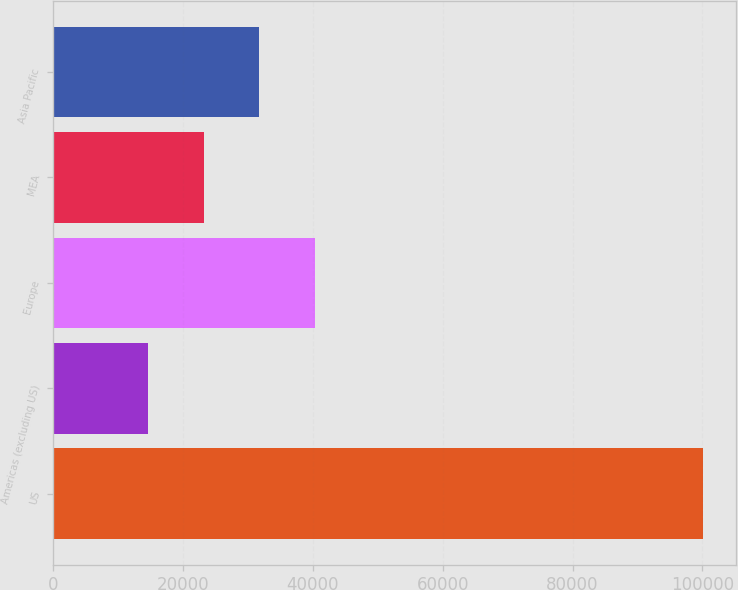<chart> <loc_0><loc_0><loc_500><loc_500><bar_chart><fcel>US<fcel>Americas (excluding US)<fcel>Europe<fcel>MEA<fcel>Asia Pacific<nl><fcel>100118<fcel>14662<fcel>40298.8<fcel>23207.6<fcel>31753.2<nl></chart> 